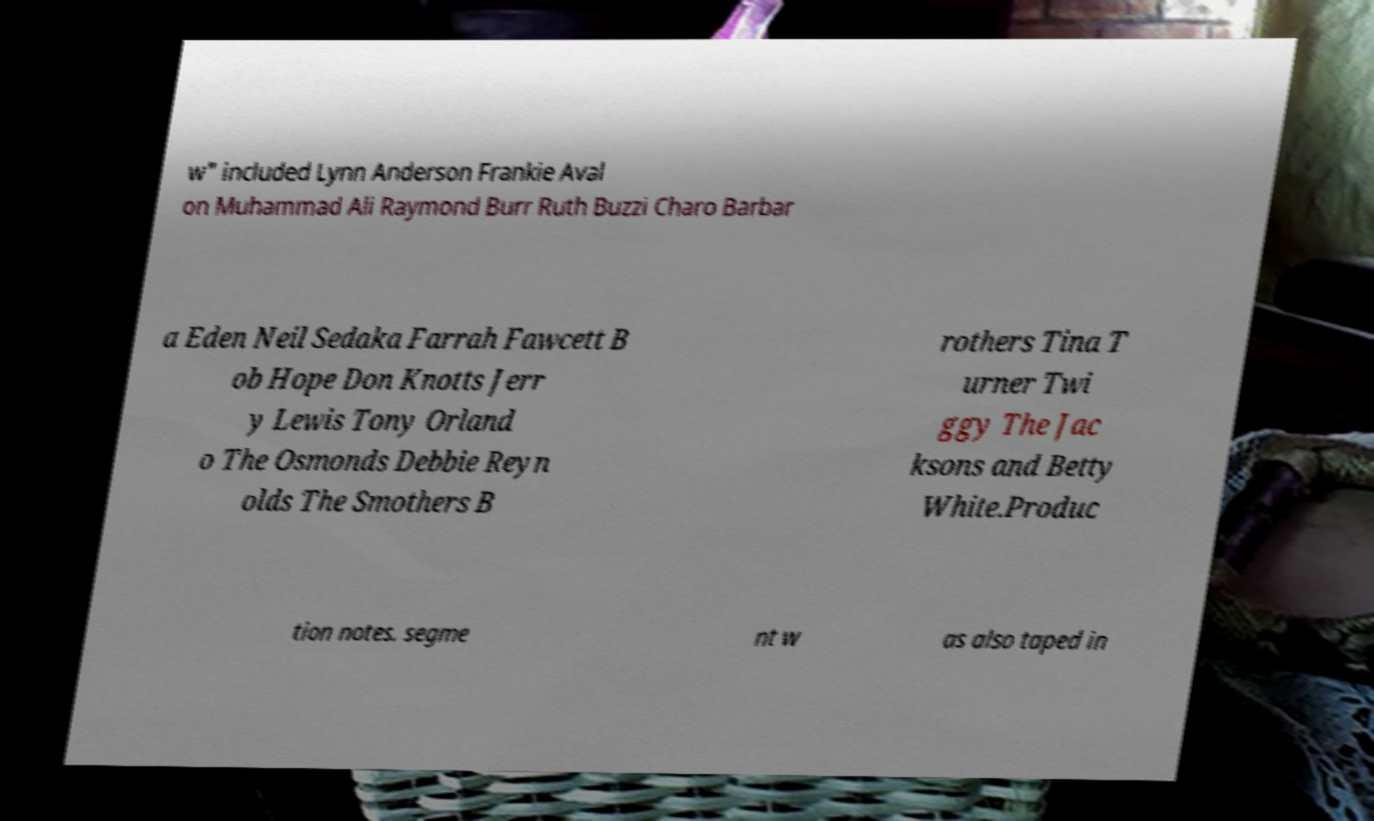Please read and relay the text visible in this image. What does it say? w" included Lynn Anderson Frankie Aval on Muhammad Ali Raymond Burr Ruth Buzzi Charo Barbar a Eden Neil Sedaka Farrah Fawcett B ob Hope Don Knotts Jerr y Lewis Tony Orland o The Osmonds Debbie Reyn olds The Smothers B rothers Tina T urner Twi ggy The Jac ksons and Betty White.Produc tion notes. segme nt w as also taped in 